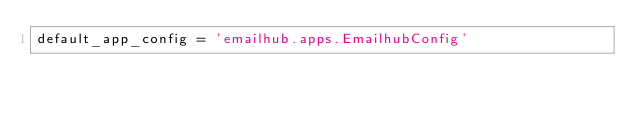<code> <loc_0><loc_0><loc_500><loc_500><_Python_>default_app_config = 'emailhub.apps.EmailhubConfig'
</code> 